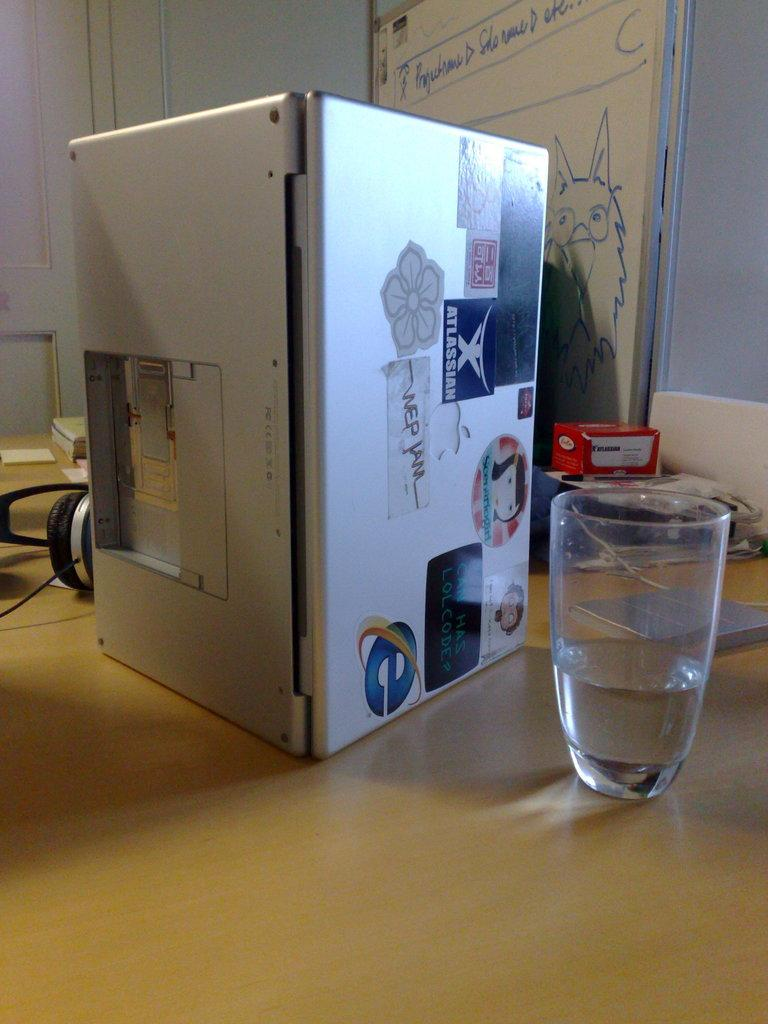<image>
Present a compact description of the photo's key features. An Internet Explorer logo has been affixed to a laptop computer. 